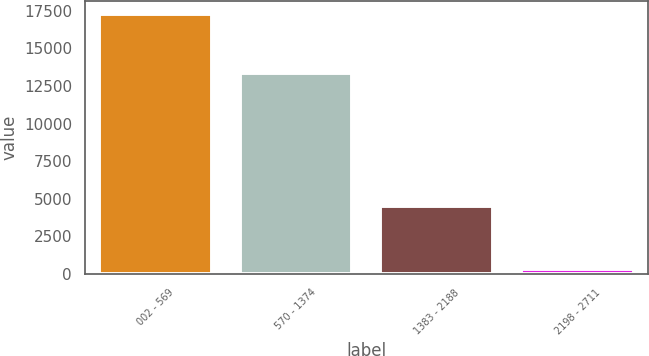Convert chart to OTSL. <chart><loc_0><loc_0><loc_500><loc_500><bar_chart><fcel>002 - 569<fcel>570 - 1374<fcel>1383 - 2188<fcel>2198 - 2711<nl><fcel>17302<fcel>13344<fcel>4499<fcel>324<nl></chart> 